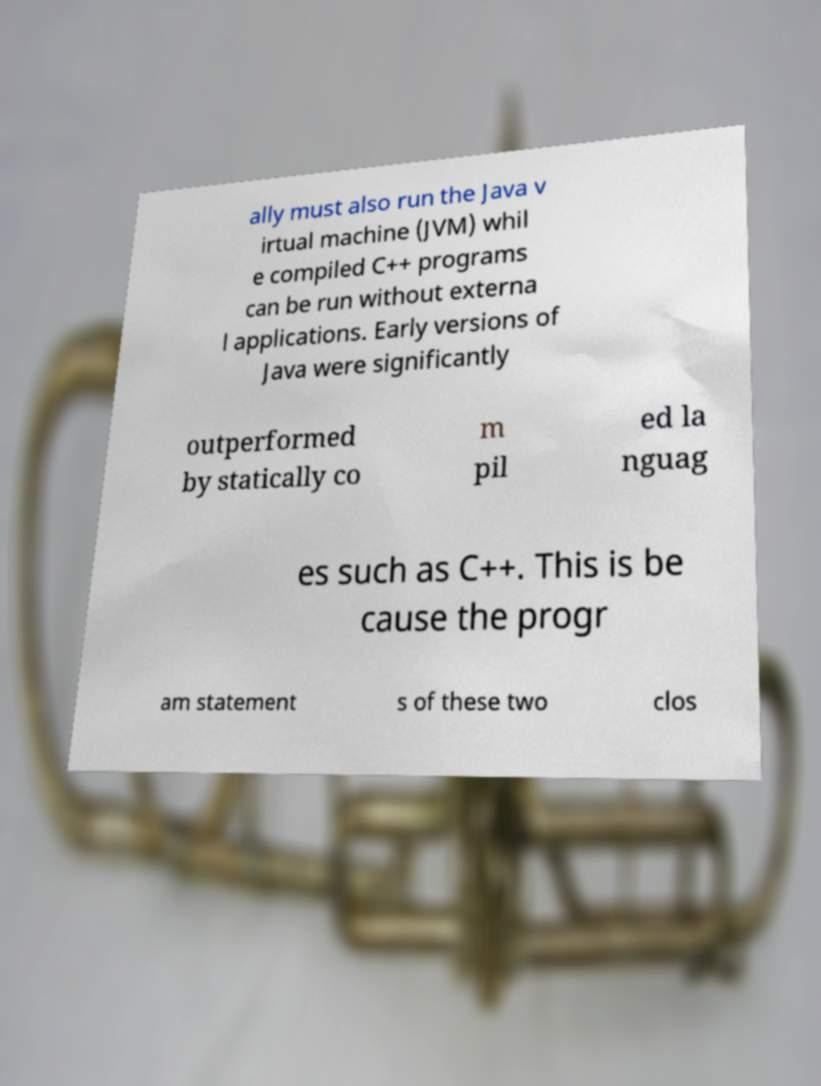Could you extract and type out the text from this image? ally must also run the Java v irtual machine (JVM) whil e compiled C++ programs can be run without externa l applications. Early versions of Java were significantly outperformed by statically co m pil ed la nguag es such as C++. This is be cause the progr am statement s of these two clos 